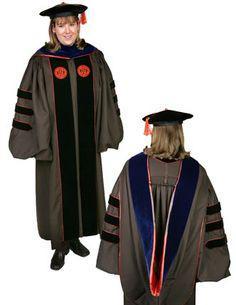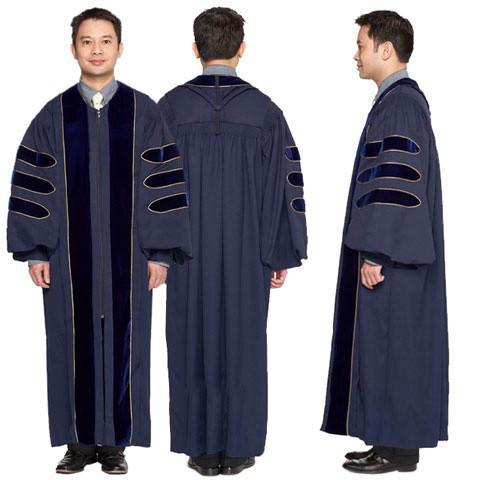The first image is the image on the left, the second image is the image on the right. Analyze the images presented: Is the assertion "One image shows the same male graduate in multiple poses, and the other image includes a female graduate." valid? Answer yes or no. Yes. The first image is the image on the left, the second image is the image on the right. For the images shown, is this caption "Three people are modeling graduation attire in one of the images." true? Answer yes or no. Yes. 